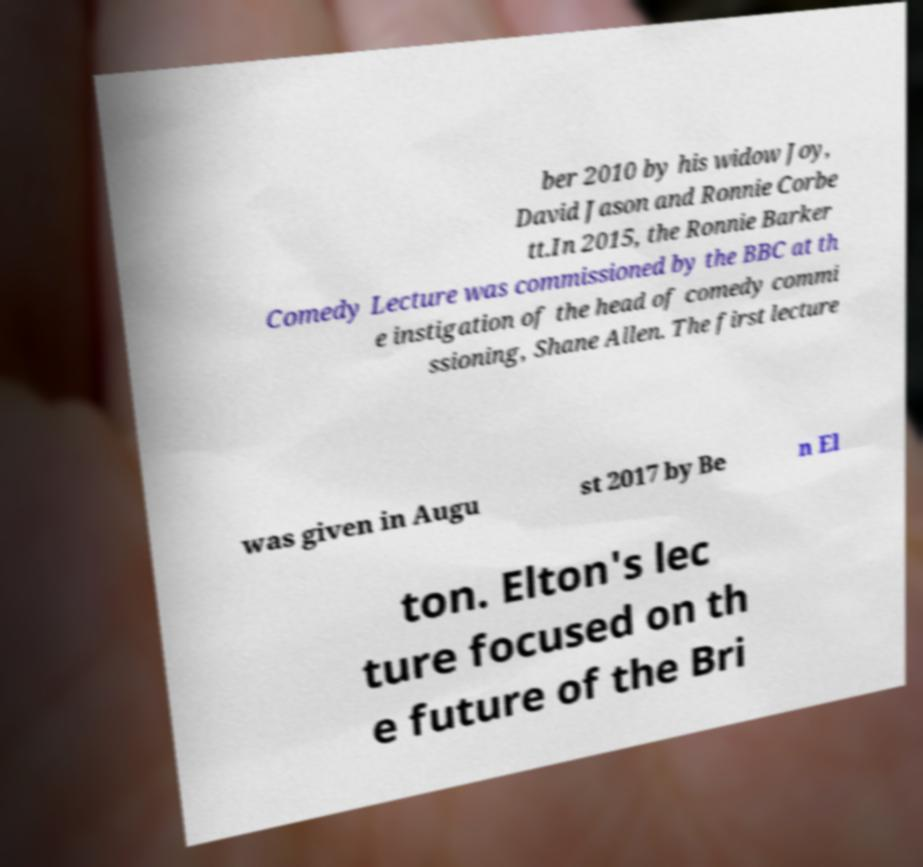Can you read and provide the text displayed in the image?This photo seems to have some interesting text. Can you extract and type it out for me? ber 2010 by his widow Joy, David Jason and Ronnie Corbe tt.In 2015, the Ronnie Barker Comedy Lecture was commissioned by the BBC at th e instigation of the head of comedy commi ssioning, Shane Allen. The first lecture was given in Augu st 2017 by Be n El ton. Elton's lec ture focused on th e future of the Bri 